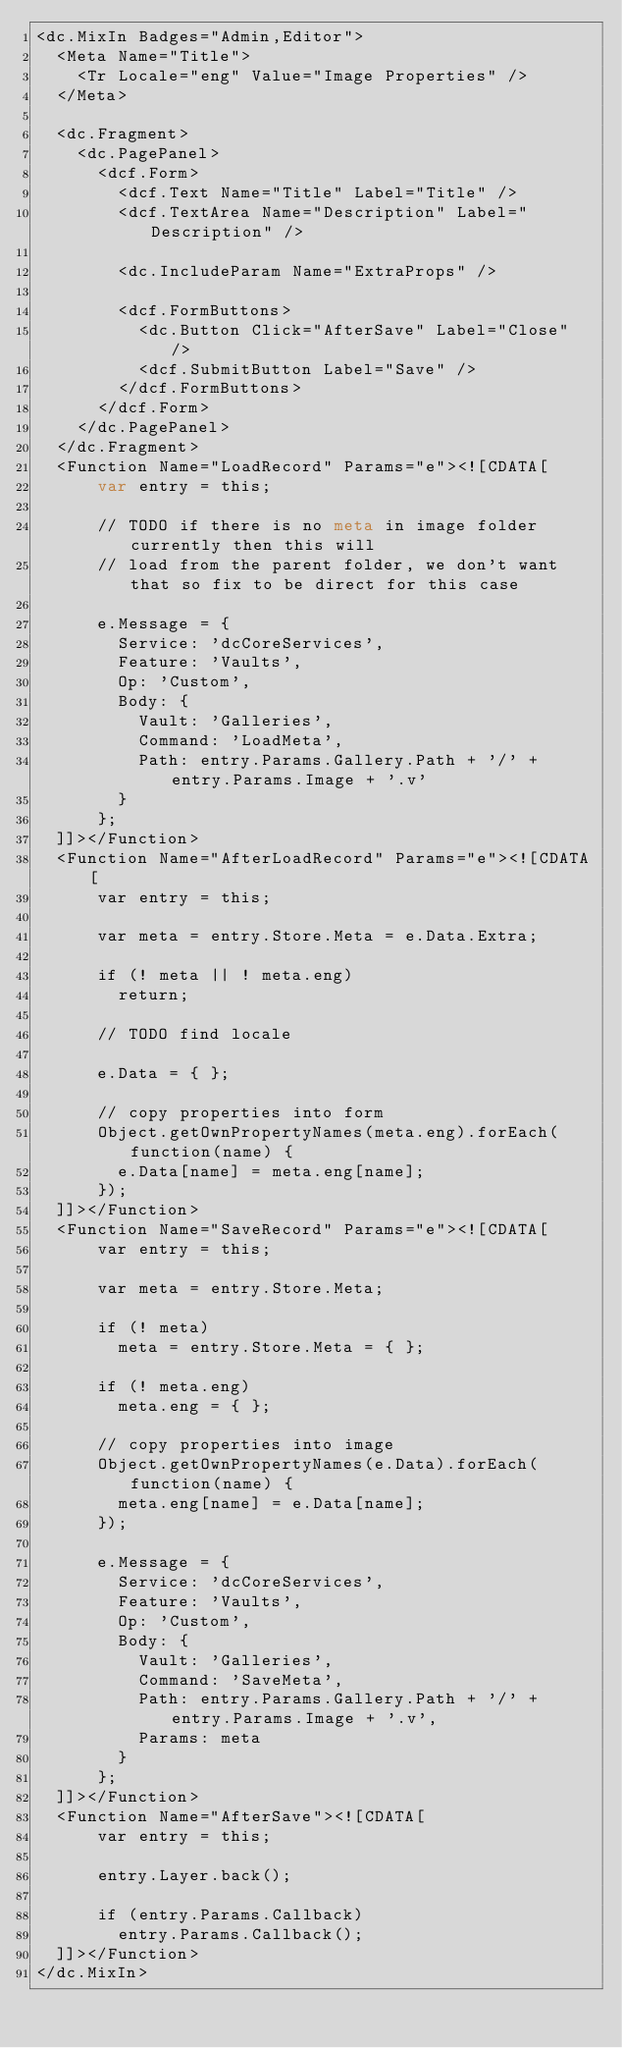Convert code to text. <code><loc_0><loc_0><loc_500><loc_500><_HTML_><dc.MixIn Badges="Admin,Editor">
	<Meta Name="Title">
		<Tr Locale="eng" Value="Image Properties" />
	</Meta>

	<dc.Fragment>
		<dc.PagePanel>
			<dcf.Form>
				<dcf.Text Name="Title" Label="Title" />
				<dcf.TextArea Name="Description" Label="Description" />

				<dc.IncludeParam Name="ExtraProps" />

				<dcf.FormButtons>
					<dc.Button Click="AfterSave" Label="Close" />
					<dcf.SubmitButton Label="Save" />
				</dcf.FormButtons>
			</dcf.Form>
		</dc.PagePanel>
	</dc.Fragment>
	<Function Name="LoadRecord" Params="e"><![CDATA[
			var entry = this;

			// TODO if there is no meta in image folder currently then this will
			// load from the parent folder, we don't want that so fix to be direct for this case

			e.Message = {
				Service: 'dcCoreServices',
				Feature: 'Vaults',
				Op: 'Custom',
				Body: {
					Vault: 'Galleries',
					Command: 'LoadMeta',
					Path: entry.Params.Gallery.Path + '/' + entry.Params.Image + '.v'
				}
			};
	]]></Function>
	<Function Name="AfterLoadRecord" Params="e"><![CDATA[
			var entry = this;

			var meta = entry.Store.Meta = e.Data.Extra;

			if (! meta || ! meta.eng)
				return;

			// TODO find locale

			e.Data = { };

			// copy properties into form
			Object.getOwnPropertyNames(meta.eng).forEach(function(name) {
				e.Data[name] = meta.eng[name];
			});
	]]></Function>
	<Function Name="SaveRecord" Params="e"><![CDATA[
			var entry = this;

			var meta = entry.Store.Meta;

			if (! meta)
				meta = entry.Store.Meta = { };

			if (! meta.eng)
				meta.eng = { };

			// copy properties into image
			Object.getOwnPropertyNames(e.Data).forEach(function(name) {
				meta.eng[name] = e.Data[name];
			});

			e.Message = {
				Service: 'dcCoreServices',
				Feature: 'Vaults',
				Op: 'Custom',
				Body: {
					Vault: 'Galleries',
					Command: 'SaveMeta',
					Path: entry.Params.Gallery.Path + '/' + entry.Params.Image + '.v',
					Params: meta
				}
			};
	]]></Function>
	<Function Name="AfterSave"><![CDATA[
			var entry = this;

			entry.Layer.back();

			if (entry.Params.Callback)
				entry.Params.Callback();
	]]></Function>
</dc.MixIn>
</code> 